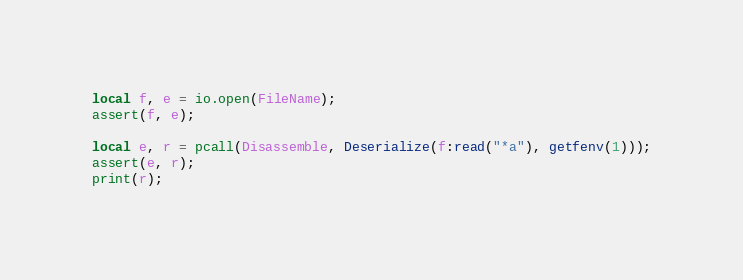<code> <loc_0><loc_0><loc_500><loc_500><_Lua_>
local f, e = io.open(FileName);
assert(f, e);

local e, r = pcall(Disassemble, Deserialize(f:read("*a"), getfenv(1)));
assert(e, r);
print(r);</code> 